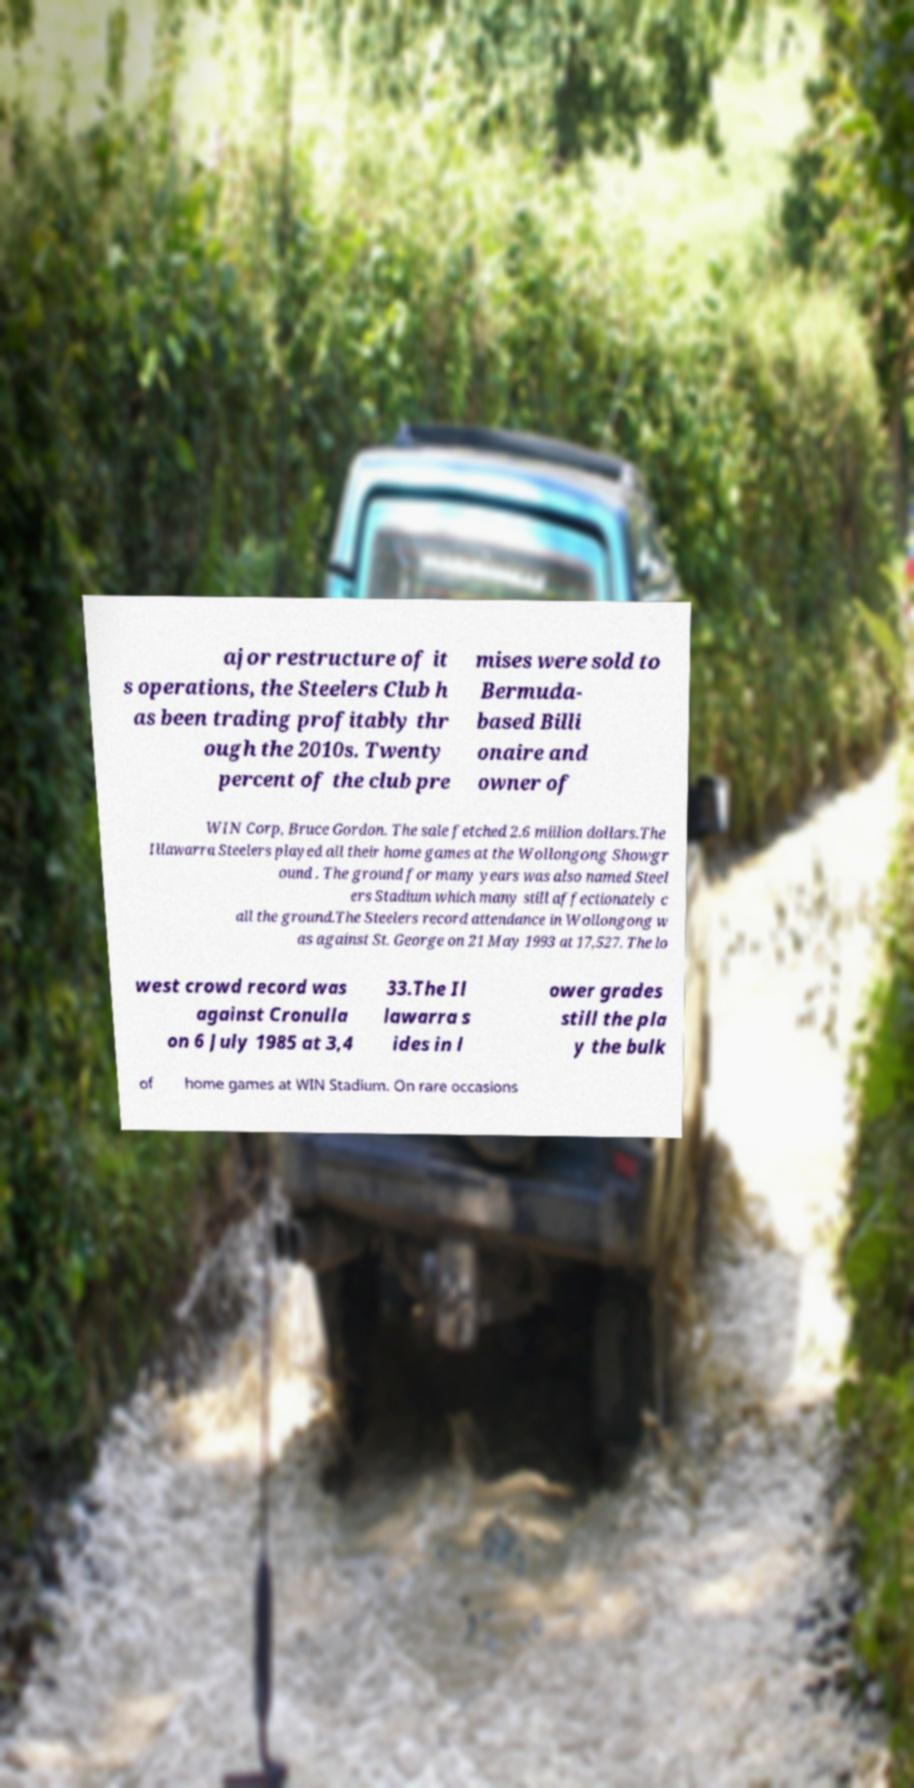There's text embedded in this image that I need extracted. Can you transcribe it verbatim? ajor restructure of it s operations, the Steelers Club h as been trading profitably thr ough the 2010s. Twenty percent of the club pre mises were sold to Bermuda- based Billi onaire and owner of WIN Corp, Bruce Gordon. The sale fetched 2.6 million dollars.The Illawarra Steelers played all their home games at the Wollongong Showgr ound . The ground for many years was also named Steel ers Stadium which many still affectionately c all the ground.The Steelers record attendance in Wollongong w as against St. George on 21 May 1993 at 17,527. The lo west crowd record was against Cronulla on 6 July 1985 at 3,4 33.The Il lawarra s ides in l ower grades still the pla y the bulk of home games at WIN Stadium. On rare occasions 